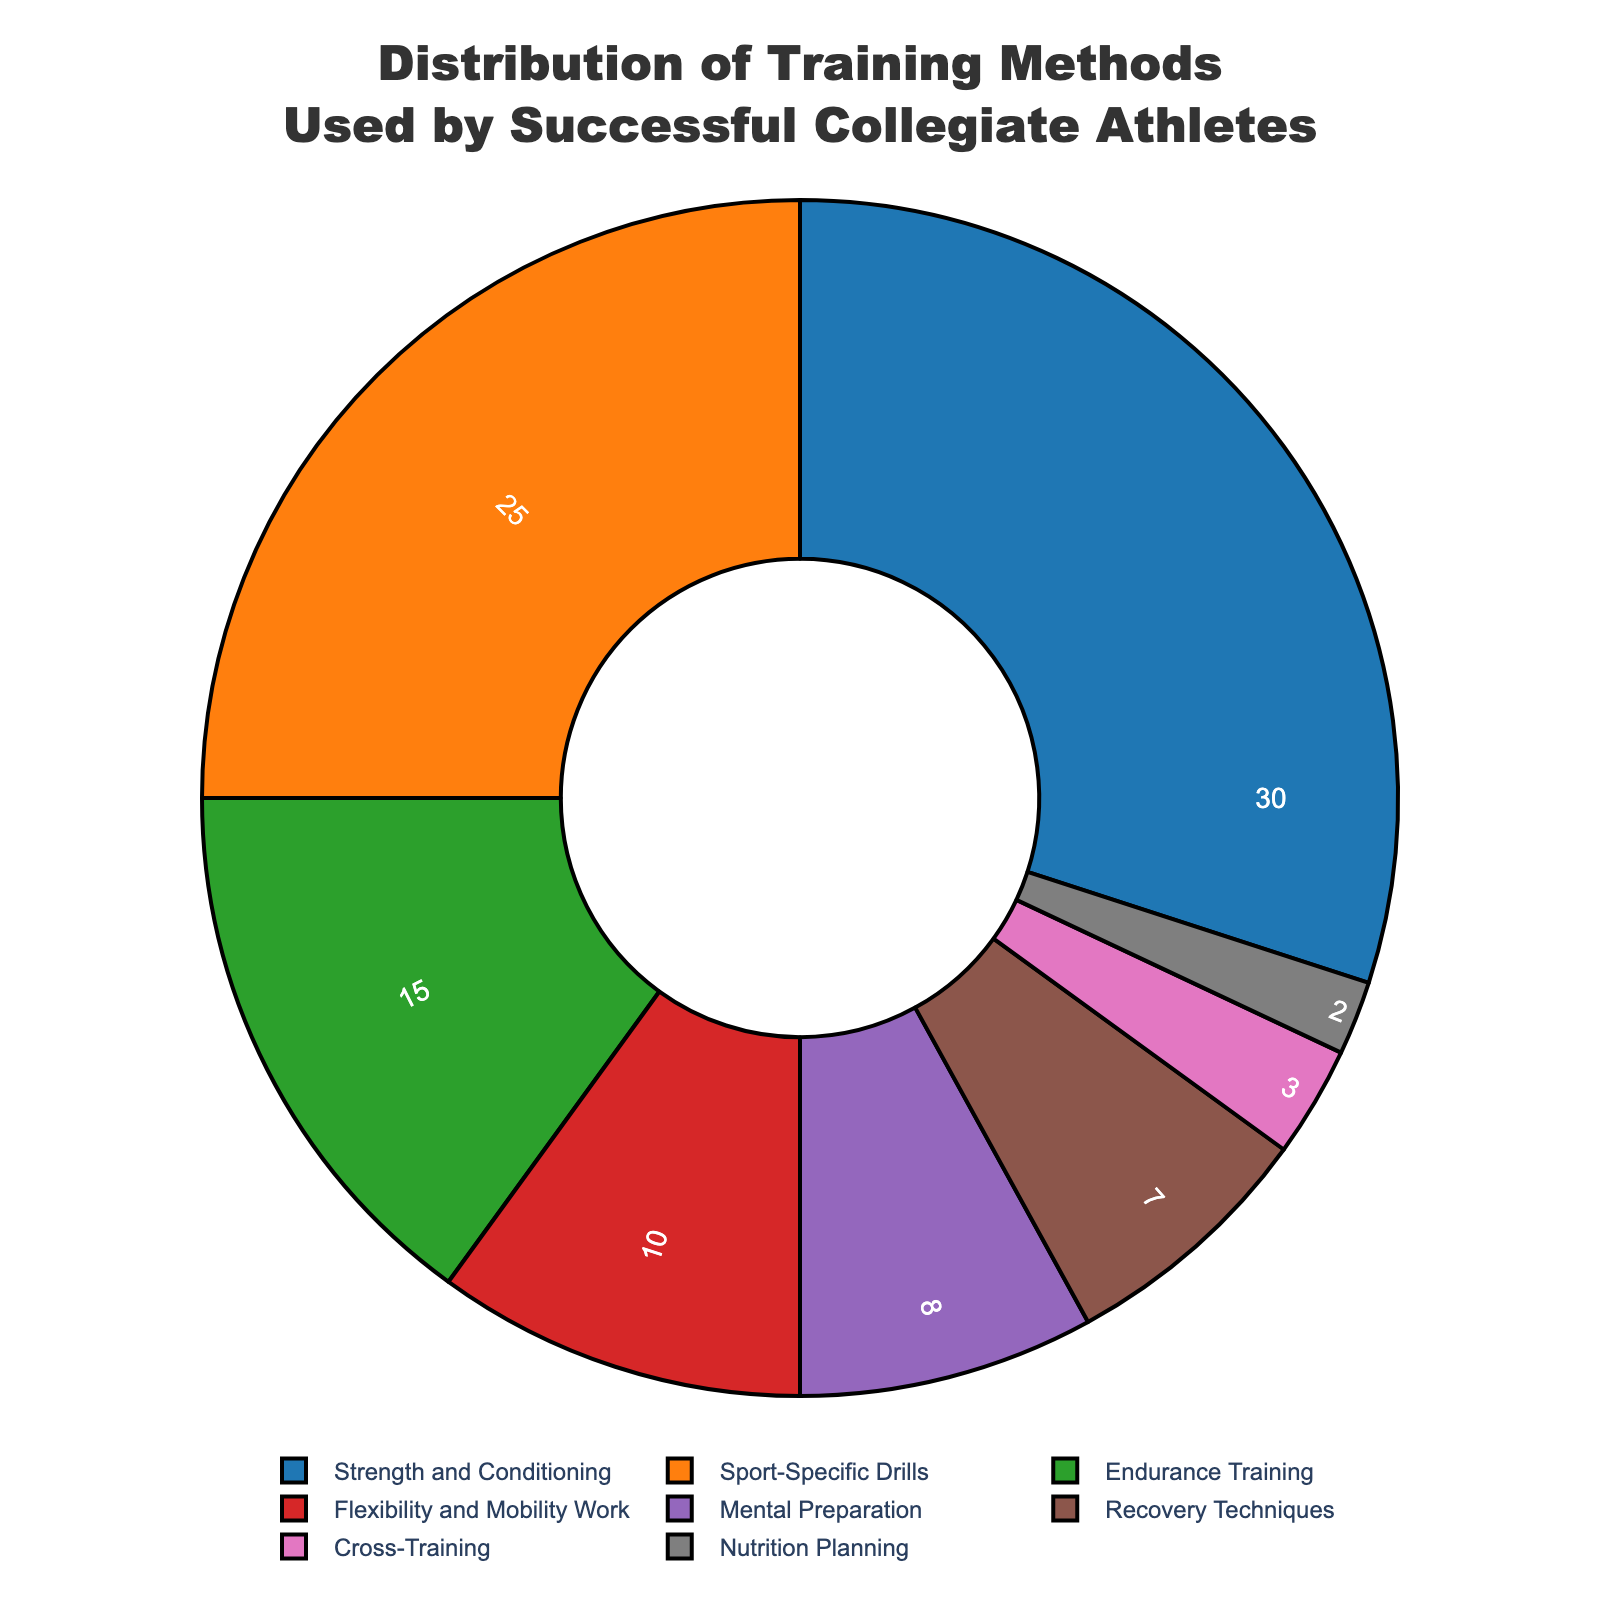Which training method is used the most by successful collegiate athletes? The slice representing "Strength and Conditioning" is the largest, with a percentage of 30%
Answer: Strength and Conditioning Which two training methods combined account for more than half of the distribution? Summing "Strength and Conditioning" (30%) and "Sport-Specific Drills" (25%) gives a total of 55%, which is more than half
Answer: Strength and Conditioning and Sport-Specific Drills How much more popular is "Strength and Conditioning" than "Endurance Training"? The percentage for "Strength and Conditioning" is 30%, and for "Endurance Training," it is 15%. The difference is 30% - 15% = 15%
Answer: 15% What is the total percentage of methods focused on physical preparation (Strength and Conditioning, Sport-Specific Drills, and Endurance Training)? Adding the percentages of "Strength and Conditioning" (30%), "Sport-Specific Drills" (25%), and "Endurance Training" (15%) gives 30% + 25% + 15% = 70%
Answer: 70% Which training method is used the least by successful collegiate athletes and what percentage does it represent? The slice representing "Nutrition Planning" is the smallest and shows a percentage of 2%
Answer: Nutrition Planning, 2% Are Recovery Techniques more popular than Mental Preparation? "Recovery Techniques" accounts for 7% while "Mental Preparation" accounts for 8%, so Recovery Techniques are less popular
Answer: No How does the popularity of Flexibility and Mobility Work compare to Endurance Training? The percentage for "Flexibility and Mobility Work" is 10%, and for "Endurance Training," it is 15%. Flexibility and Mobility Work is less popular by 15% - 10% = 5%
Answer: Flexibility and Mobility Work is less popular by 5% Considering all training methods, what is the average percentage of their use? The total percentage for 8 training methods is 100%. Dividing by the number of methods, 100% / 8 = 12.5%
Answer: 12.5% Is Sport-Specific Drills equally popular as Strength and Conditioning? The percentage for "Sport-Specific Drills" is 25%, whereas for "Strength and Conditioning," it is 30%, so they are not equally popular
Answer: No Which category accounts for a larger portion: Mental Preparation plus Nutrition Planning or Cross-Training plus Recovery Techniques? Summing the percentages: Mental Preparation (8%) + Nutrition Planning (2%) = 10%; Cross-Training (3%) + Recovery Techniques (7%) = 10%. Both categories account for the same percentage
Answer: They account for the same percentage 